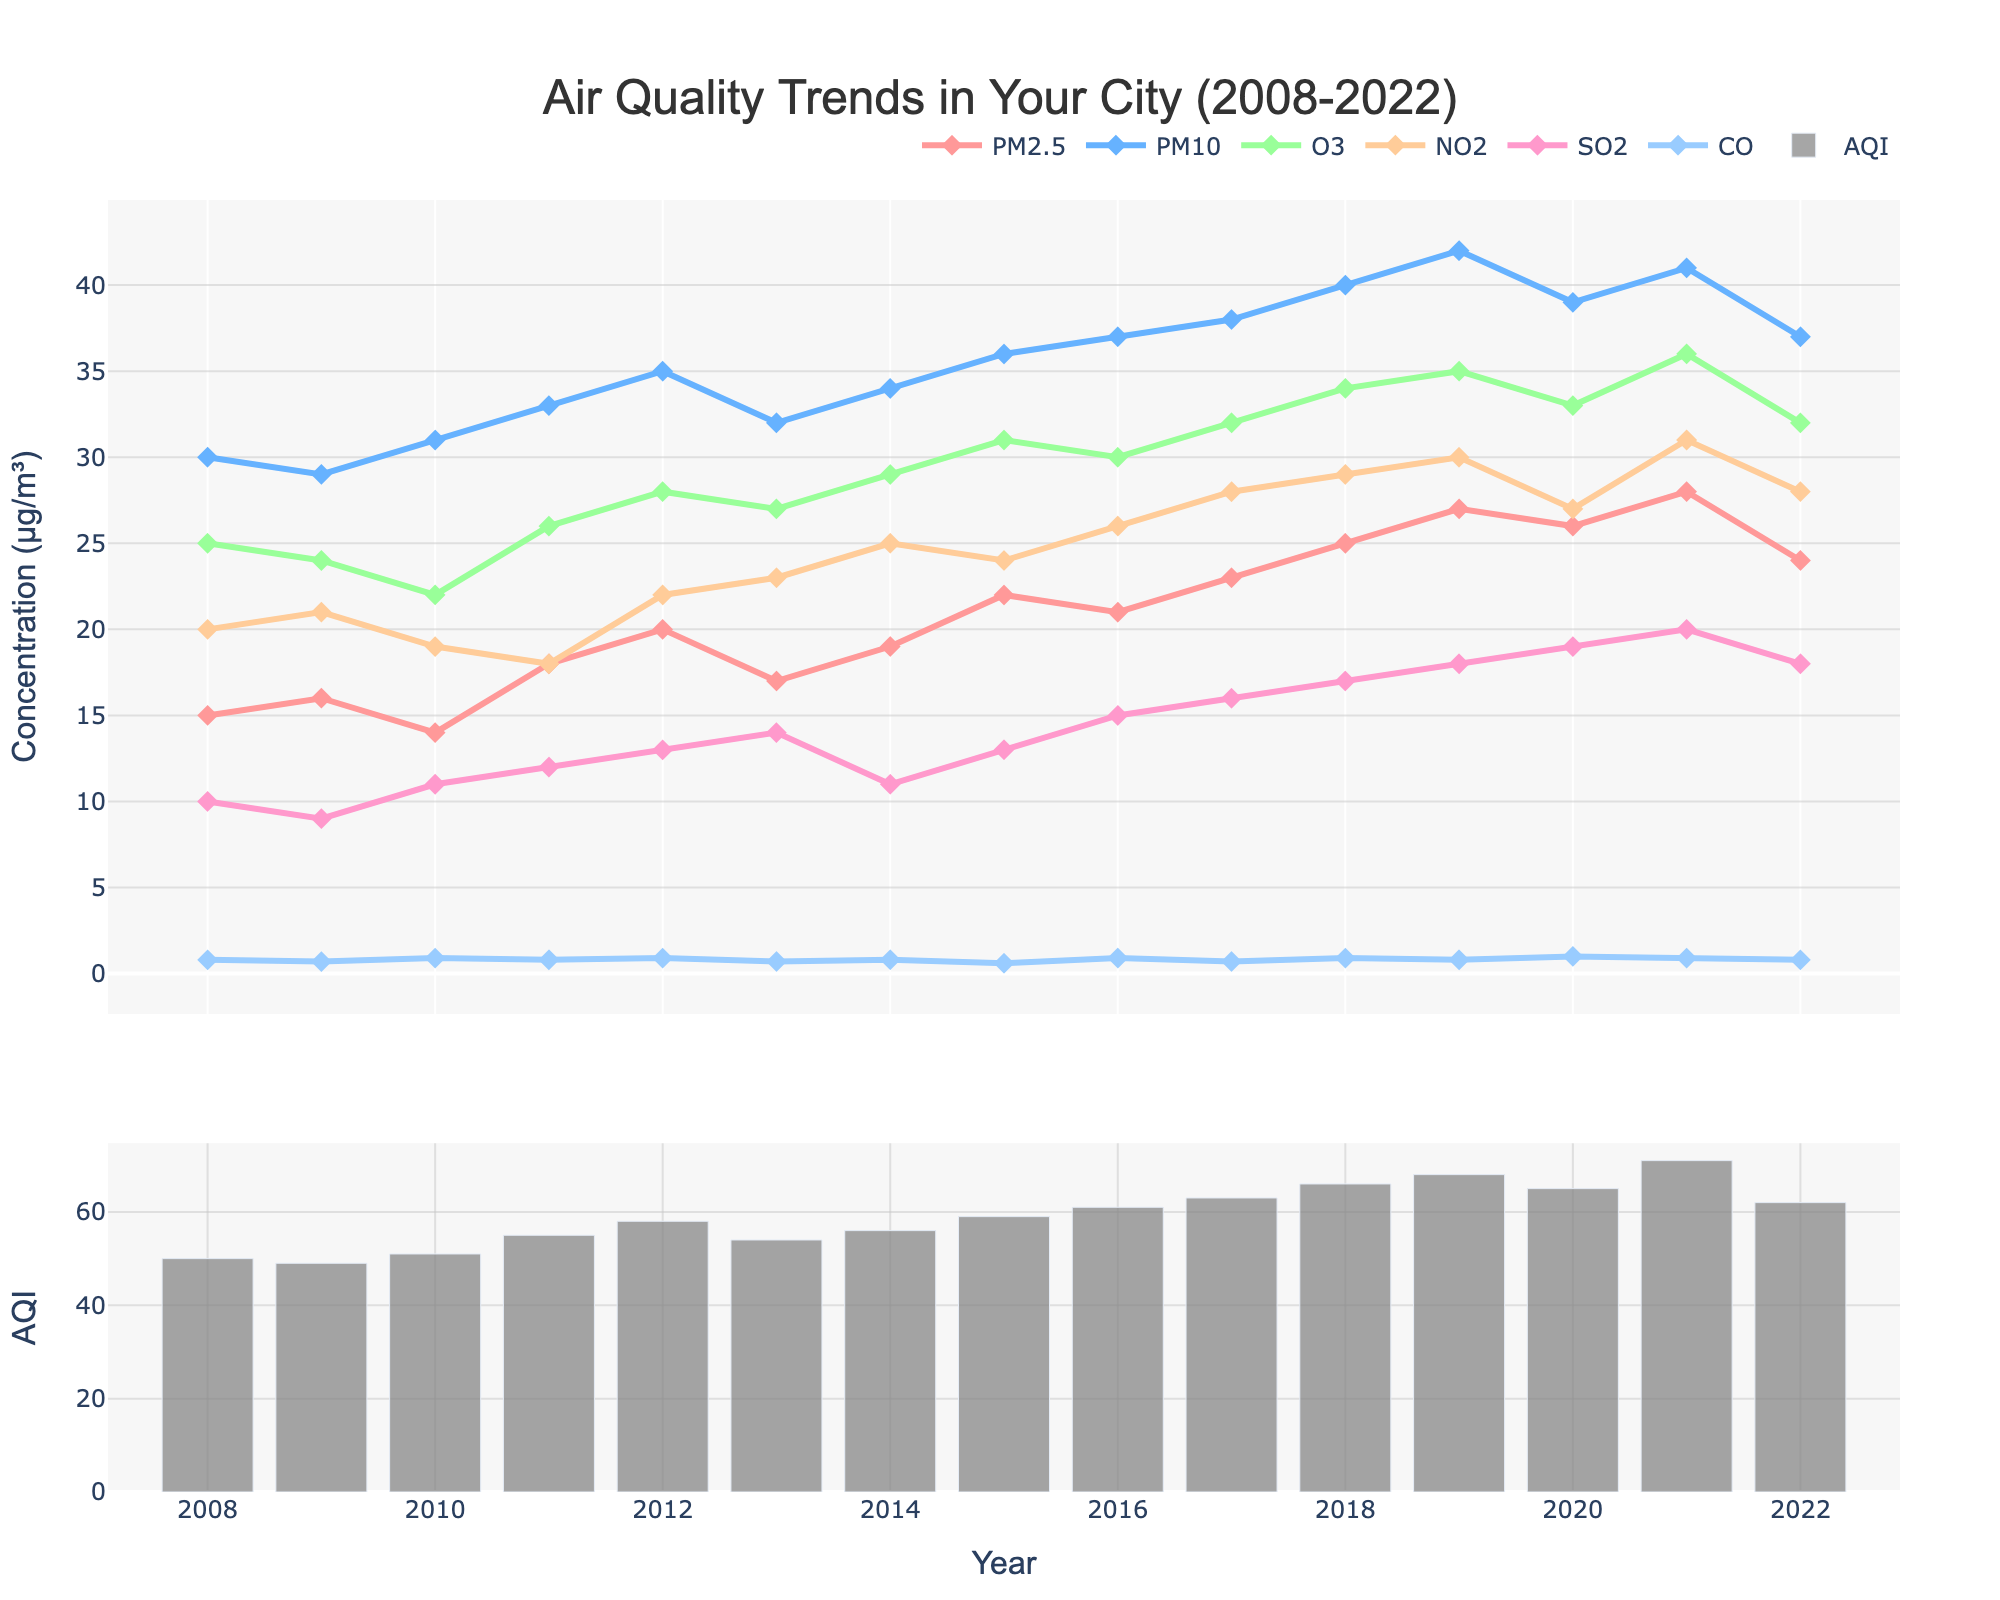What is the title of the figure? The title of the figure is located at the top and it summarizes the content being displayed. The title reads "Air Quality Trends in Your City (2008-2022)".
Answer: Air Quality Trends in Your City (2008-2022) Which year had the highest AQI? The AQI values are represented by the bar plot in the second subplot. By examining the heights of the bars, the highest AQI is in the year 2021.
Answer: 2021 What is the trend for PM2.5 throughout the 15 years? The trend of PM2.5 is shown in the line plot of the first subplot. Tracking the purple line, it starts around 15 µg/m³ in 2008, fluctuates over the years, and ends at 24 µg/m³ in 2022.
Answer: Increasing trend Which pollutant shows the highest concentration in 2022? The line plot shows the concentrations of different pollutants in 2022. PM10 is represented by a blue line and shows the highest value among all pollutants in 2022.
Answer: PM10 How does the AQI in 2022 compare to that in 2021? From the bar plot, the AQI in 2022 is lower than in 2021. The height of the bar in 2021 is higher compared to the bar in 2022.
Answer: Lower Which year had the maximum concentration of CO, and what was the concentration? CO concentrations are indicated by the light blue diamond-mark line. In 2020, the concentration of CO reaches its peak at 1.0 µg/m³.
Answer: 2020 and 1.0 µg/m³ What was the average AQI from 2008 to 2012? To find the average AQI from 2008 to 2012, sum the AQIs for these years (50, 49, 51, 55, 58) and divide by the number of years. (50 + 49 + 51 + 55 + 58) / 5 = 263 / 5 = 52.6
Answer: 52.6 In which years did PM10 exceed 35 µg/m³? From the line plot, PM10 values exceed 35 µg/m³ in the years 2015, 2016, 2017, 2018, 2019, 2020, and 2021.
Answer: 2015, 2016, 2017, 2018, 2019, 2020, 2021 What is the total increase in AQI from 2008 to 2021? The AQI in 2008 is 50 and in 2021 is 71. The total increase is calculated by subtracting 50 from 71. 71 - 50 = 21
Answer: 21 What is the pattern of O3 concentration over the years? The O3 concentration is shown by the green line. The pattern shows an overall increasing trend from 2008 to 2021, with a slight dip in 2010 and 2022.
Answer: Increasing trend with fluctuations 